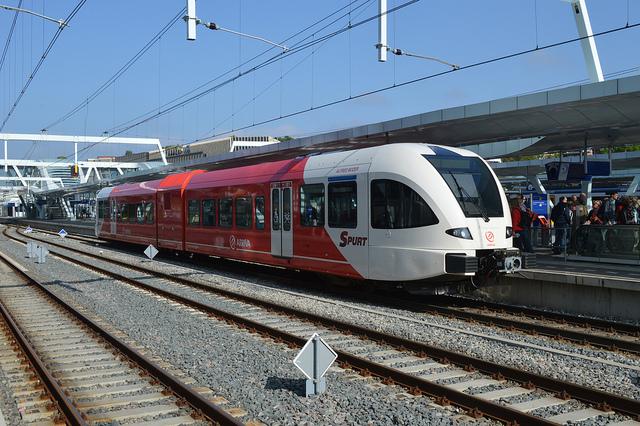What is said on the side of the train?
Short answer required. Sport. What time of day is it?
Answer briefly. Noon. Is this a bus or train?
Give a very brief answer. Train. Is it cloudy?
Give a very brief answer. No. What mode of transportation is shown?
Concise answer only. Train. Where is this train going?
Write a very short answer. East. 